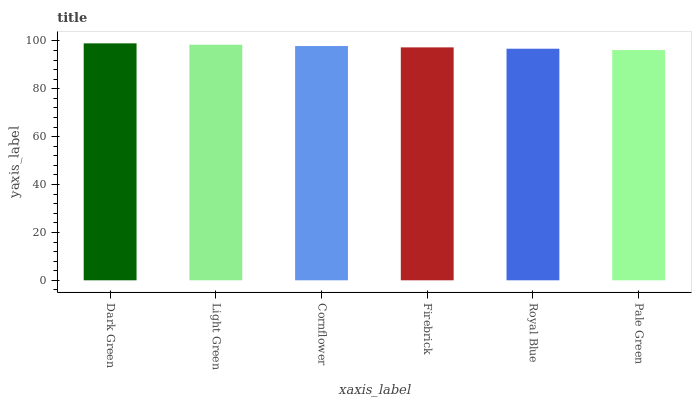Is Pale Green the minimum?
Answer yes or no. Yes. Is Dark Green the maximum?
Answer yes or no. Yes. Is Light Green the minimum?
Answer yes or no. No. Is Light Green the maximum?
Answer yes or no. No. Is Dark Green greater than Light Green?
Answer yes or no. Yes. Is Light Green less than Dark Green?
Answer yes or no. Yes. Is Light Green greater than Dark Green?
Answer yes or no. No. Is Dark Green less than Light Green?
Answer yes or no. No. Is Cornflower the high median?
Answer yes or no. Yes. Is Firebrick the low median?
Answer yes or no. Yes. Is Pale Green the high median?
Answer yes or no. No. Is Light Green the low median?
Answer yes or no. No. 